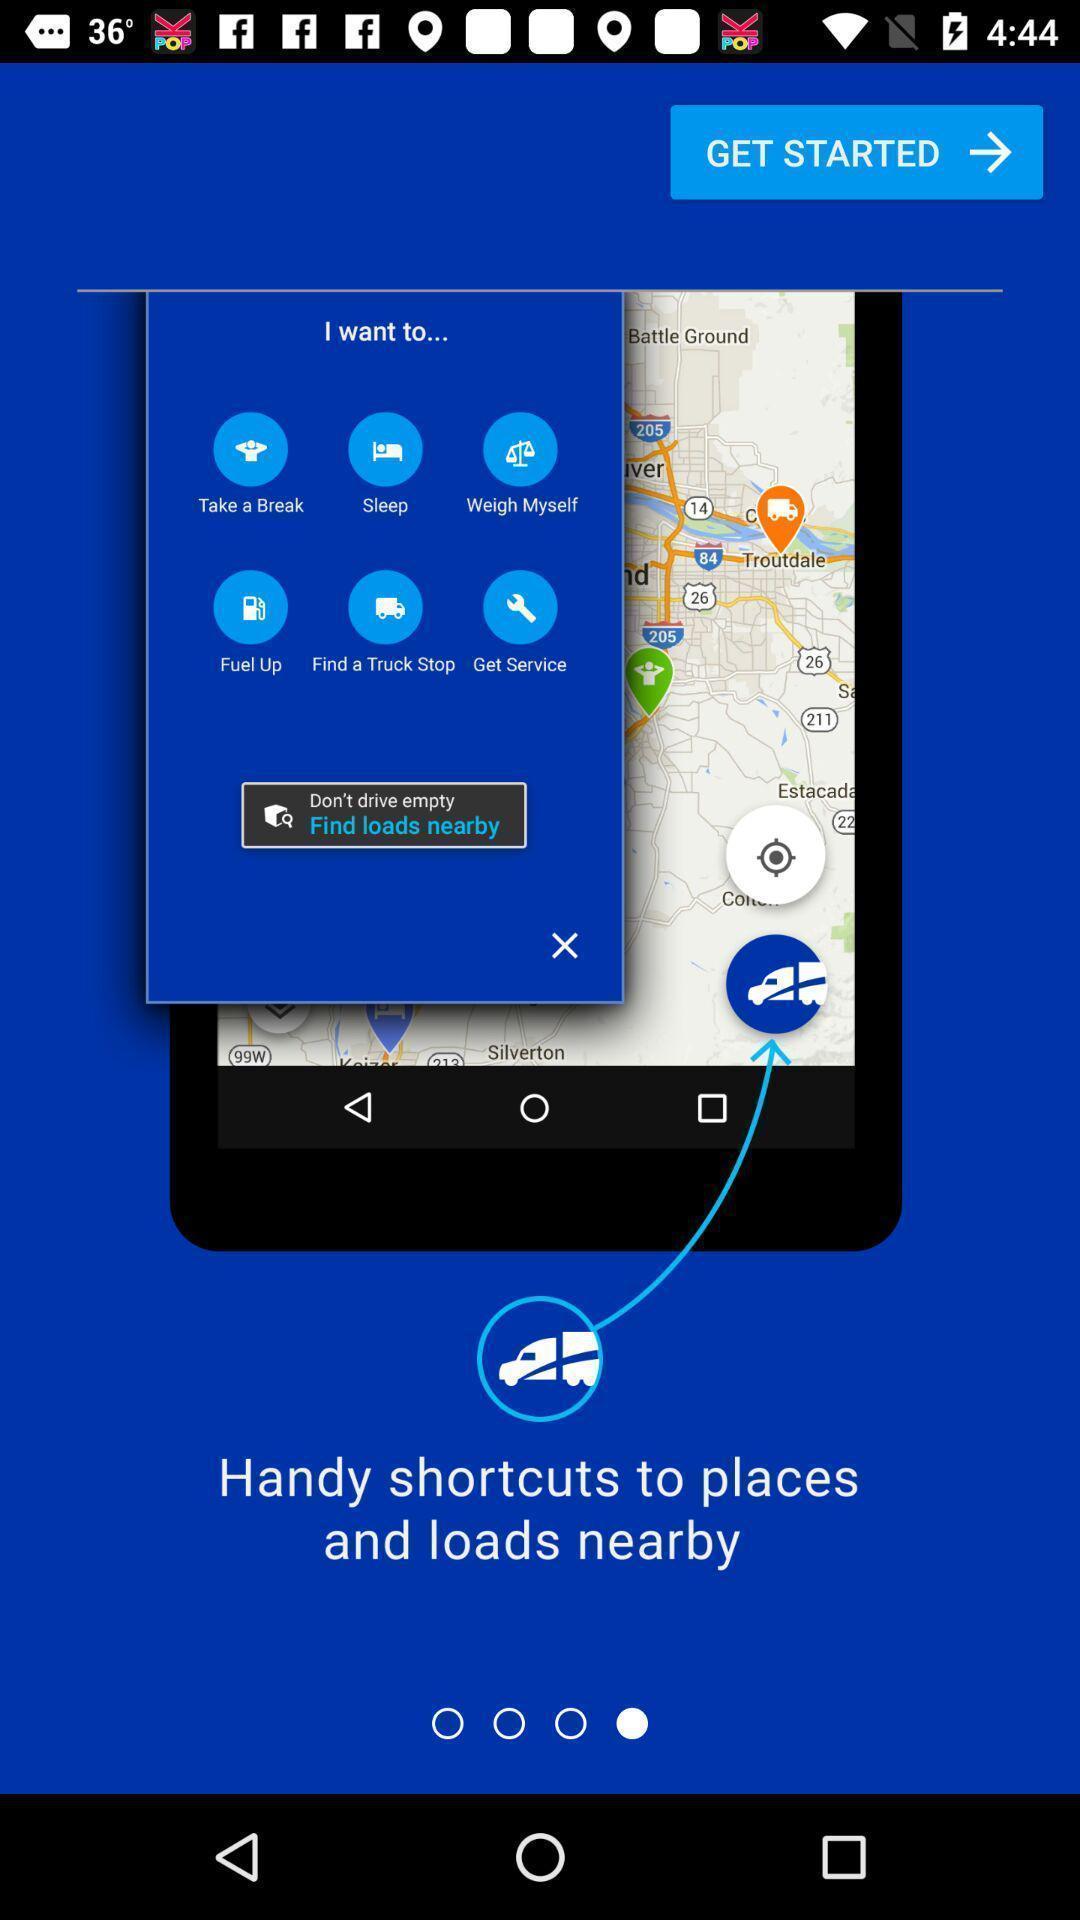Explain what's happening in this screen capture. Welcome page to find the trucker near by. 